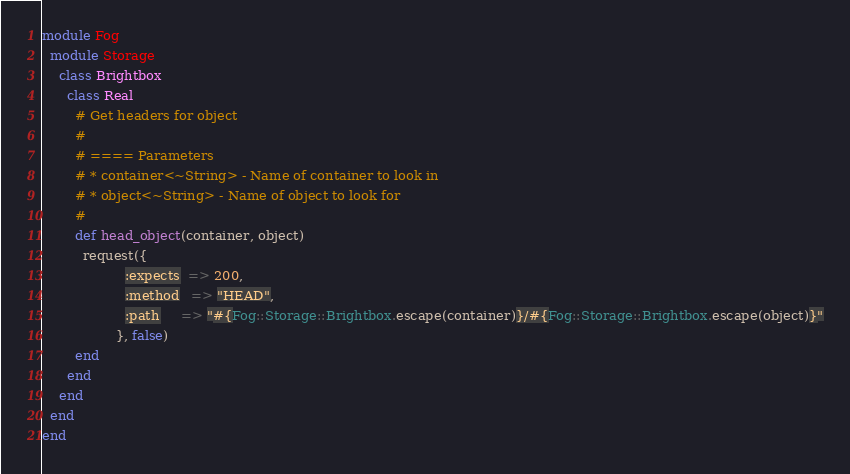<code> <loc_0><loc_0><loc_500><loc_500><_Ruby_>module Fog
  module Storage
    class Brightbox
      class Real
        # Get headers for object
        #
        # ==== Parameters
        # * container<~String> - Name of container to look in
        # * object<~String> - Name of object to look for
        #
        def head_object(container, object)
          request({
                    :expects  => 200,
                    :method   => "HEAD",
                    :path     => "#{Fog::Storage::Brightbox.escape(container)}/#{Fog::Storage::Brightbox.escape(object)}"
                  }, false)
        end
      end
    end
  end
end
</code> 